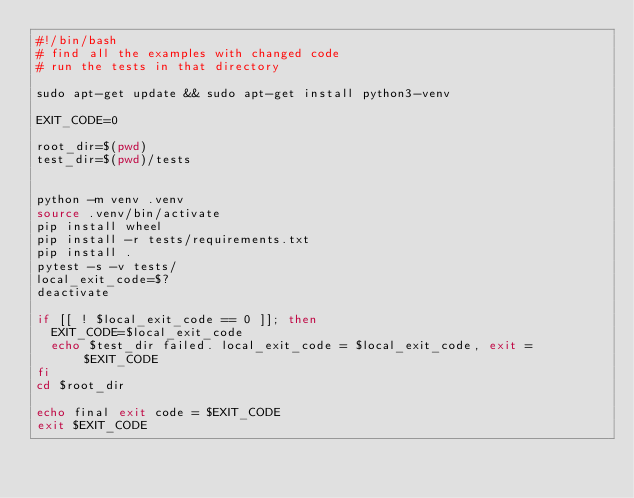<code> <loc_0><loc_0><loc_500><loc_500><_Bash_>#!/bin/bash
# find all the examples with changed code
# run the tests in that directory

sudo apt-get update && sudo apt-get install python3-venv

EXIT_CODE=0

root_dir=$(pwd)
test_dir=$(pwd)/tests


python -m venv .venv
source .venv/bin/activate
pip install wheel
pip install -r tests/requirements.txt
pip install .
pytest -s -v tests/
local_exit_code=$?
deactivate

if [[ ! $local_exit_code == 0 ]]; then
  EXIT_CODE=$local_exit_code
  echo $test_dir failed. local_exit_code = $local_exit_code, exit = $EXIT_CODE
fi
cd $root_dir

echo final exit code = $EXIT_CODE
exit $EXIT_CODE</code> 